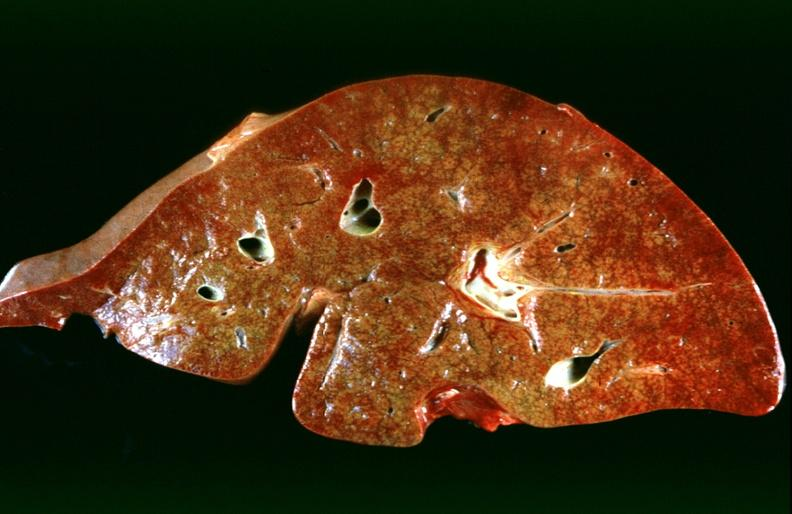why does this image show hepatic congestion?
Answer the question using a single word or phrase. Due to congestive heart failure 